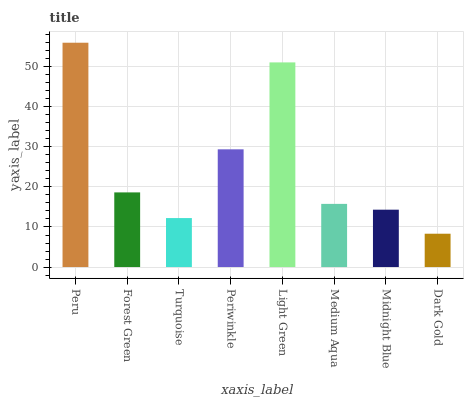Is Dark Gold the minimum?
Answer yes or no. Yes. Is Peru the maximum?
Answer yes or no. Yes. Is Forest Green the minimum?
Answer yes or no. No. Is Forest Green the maximum?
Answer yes or no. No. Is Peru greater than Forest Green?
Answer yes or no. Yes. Is Forest Green less than Peru?
Answer yes or no. Yes. Is Forest Green greater than Peru?
Answer yes or no. No. Is Peru less than Forest Green?
Answer yes or no. No. Is Forest Green the high median?
Answer yes or no. Yes. Is Medium Aqua the low median?
Answer yes or no. Yes. Is Peru the high median?
Answer yes or no. No. Is Midnight Blue the low median?
Answer yes or no. No. 